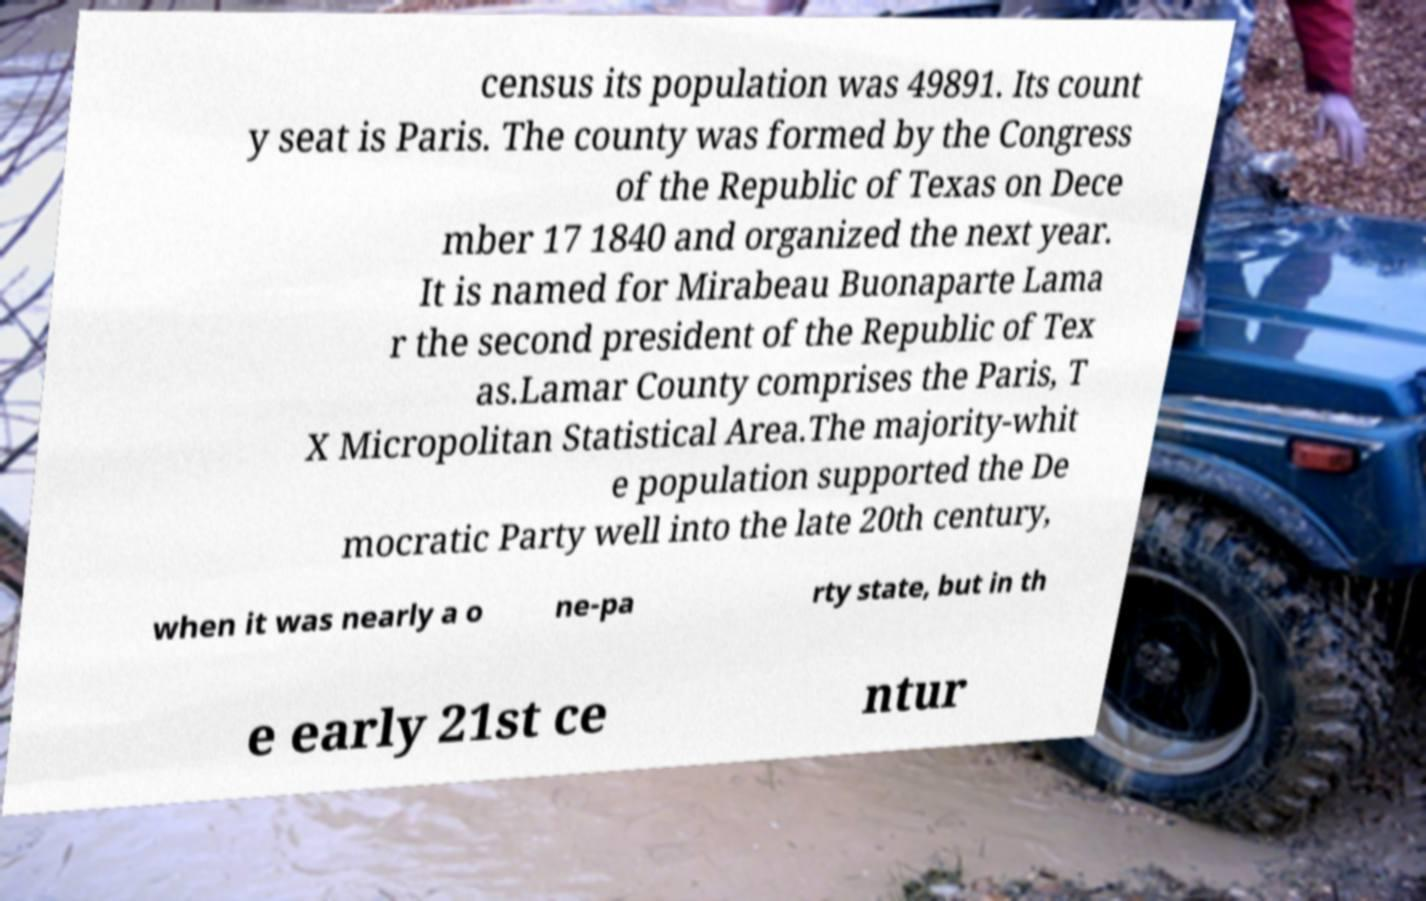What messages or text are displayed in this image? I need them in a readable, typed format. census its population was 49891. Its count y seat is Paris. The county was formed by the Congress of the Republic of Texas on Dece mber 17 1840 and organized the next year. It is named for Mirabeau Buonaparte Lama r the second president of the Republic of Tex as.Lamar County comprises the Paris, T X Micropolitan Statistical Area.The majority-whit e population supported the De mocratic Party well into the late 20th century, when it was nearly a o ne-pa rty state, but in th e early 21st ce ntur 